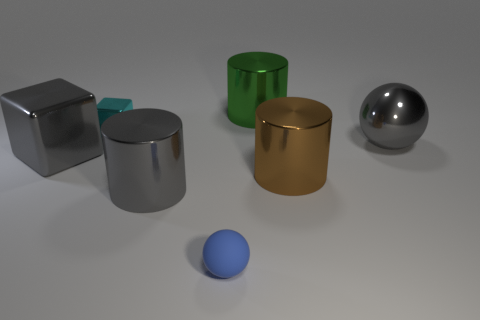Is there any other thing that has the same material as the tiny blue sphere?
Ensure brevity in your answer.  No. How many shiny balls are behind the large gray metal cube?
Give a very brief answer. 1. Do the large brown object and the big object behind the large metallic ball have the same shape?
Keep it short and to the point. Yes. Are there any large shiny objects that have the same shape as the blue matte object?
Give a very brief answer. Yes. What is the shape of the small thing behind the large gray shiny object on the right side of the green cylinder?
Your answer should be compact. Cube. What shape is the gray object that is in front of the brown cylinder?
Make the answer very short. Cylinder. Does the big metallic cylinder that is on the left side of the tiny blue rubber ball have the same color as the thing that is on the right side of the large brown metal cylinder?
Ensure brevity in your answer.  Yes. How many big gray metal things are both behind the large gray cylinder and to the right of the small cyan cube?
Your answer should be compact. 1. The gray cylinder that is made of the same material as the large green cylinder is what size?
Provide a short and direct response. Large. The green shiny cylinder is what size?
Keep it short and to the point. Large. 